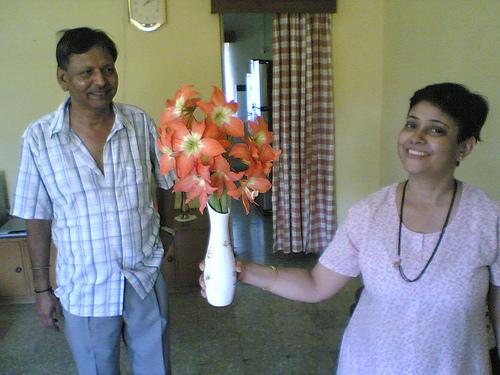What else is visible?
Be succinct. Flowers. How many pieces of jewelry are in the photo?
Write a very short answer. 3. Are these people are standing outside?
Write a very short answer. No. What color are the flowers?
Answer briefly. Orange. 